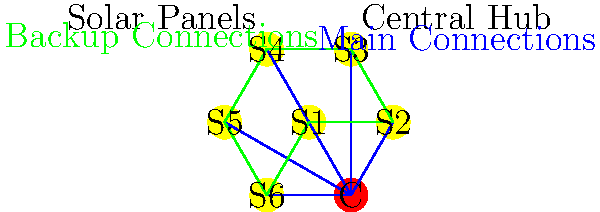In the diagram, a solar-powered grid is represented where S1 to S6 are solar panels, and C is the central hub. The blue lines represent main power connections, and the green lines represent backup connections. If any two adjacent solar panels and their main connections to the central hub fail simultaneously, what is the minimum number of backup connections (green lines) that need to be operational to ensure all functioning solar panels remain connected to the central hub? To solve this problem, we'll follow these steps:

1) First, we need to understand the worst-case scenario: two adjacent solar panels failing along with their main connections to the central hub.

2) In this case, we'll have four remaining solar panels that need to stay connected to the central hub.

3) The backup connections (green lines) form a hexagon. In graph theory, this is known as a cycle graph.

4) When two adjacent nodes fail in a cycle graph, the remaining nodes can still be connected using the edges of the cycle.

5) To connect the four remaining nodes to each other and to the central hub, we need a minimum of three edges:
   - One edge to connect the two nodes adjacent to the failed ones
   - Two edges to connect this path to the central hub

6) Therefore, regardless of which two adjacent solar panels fail, we always need a minimum of 3 backup connections to ensure all functioning solar panels remain connected to the central hub.

7) It's worth noting that these 3 connections don't need to be predetermined. Any 3 of the green backup connections that fulfill the above requirements would be sufficient.
Answer: 3 backup connections 